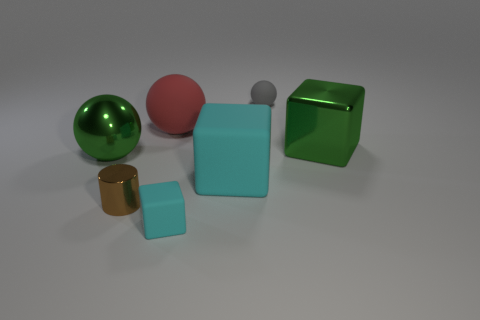Add 1 gray spheres. How many objects exist? 8 Subtract all spheres. How many objects are left? 4 Subtract 1 red balls. How many objects are left? 6 Subtract all tiny purple matte cubes. Subtract all large matte things. How many objects are left? 5 Add 6 tiny gray rubber things. How many tiny gray rubber things are left? 7 Add 4 small yellow shiny spheres. How many small yellow shiny spheres exist? 4 